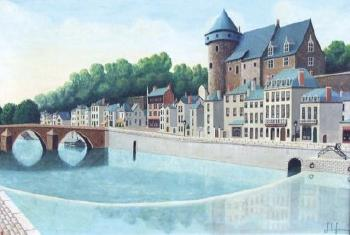What season do you think it is in this painting, and why? Based on the lush greenery in the background and the clear, calm waters, it is likely that the season depicted is either late spring or early summer. The vibrant colors and bright, clear sky suggest a time when the weather is warm without being too hot, allowing for the full bloom of foliage along the riverbanks. Which part of the town would make the best spot for a picnic and why? The best spot for a picnic would likely be by the riverbank near the bridge. The area offers a picturesque view of the water and the town, with the sound of gentle flowing water adding to a tranquil atmosphere. The lush green area behind the buildings and around the castle-like structure would provide shade and a comfortable place to relax and enjoy a meal. 